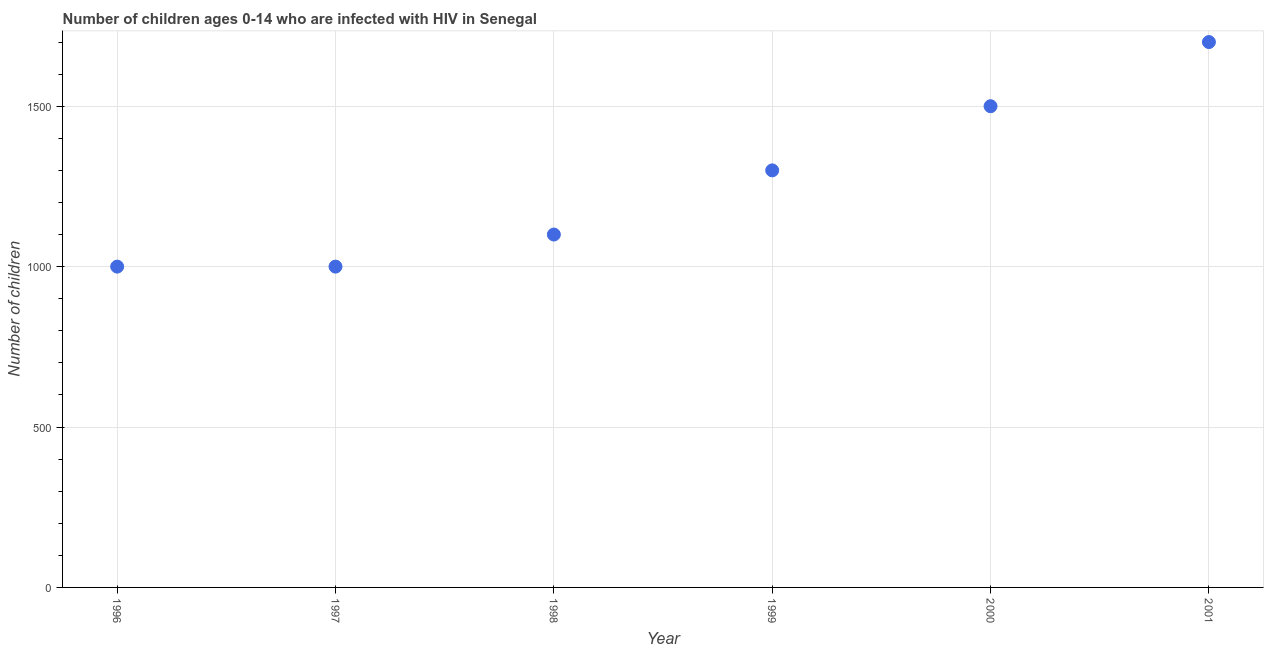What is the number of children living with hiv in 1996?
Make the answer very short. 1000. Across all years, what is the maximum number of children living with hiv?
Provide a succinct answer. 1700. Across all years, what is the minimum number of children living with hiv?
Your answer should be very brief. 1000. In which year was the number of children living with hiv maximum?
Offer a very short reply. 2001. What is the sum of the number of children living with hiv?
Make the answer very short. 7600. What is the difference between the number of children living with hiv in 1999 and 2001?
Provide a short and direct response. -400. What is the average number of children living with hiv per year?
Your answer should be very brief. 1266.67. What is the median number of children living with hiv?
Ensure brevity in your answer.  1200. In how many years, is the number of children living with hiv greater than 900 ?
Keep it short and to the point. 6. Do a majority of the years between 1997 and 1999 (inclusive) have number of children living with hiv greater than 400 ?
Make the answer very short. Yes. What is the ratio of the number of children living with hiv in 1997 to that in 2000?
Provide a succinct answer. 0.67. Is the number of children living with hiv in 1996 less than that in 1997?
Ensure brevity in your answer.  No. Is the sum of the number of children living with hiv in 1996 and 1997 greater than the maximum number of children living with hiv across all years?
Give a very brief answer. Yes. What is the difference between the highest and the lowest number of children living with hiv?
Make the answer very short. 700. In how many years, is the number of children living with hiv greater than the average number of children living with hiv taken over all years?
Your answer should be very brief. 3. How many dotlines are there?
Keep it short and to the point. 1. How many years are there in the graph?
Provide a succinct answer. 6. Does the graph contain grids?
Your answer should be compact. Yes. What is the title of the graph?
Provide a short and direct response. Number of children ages 0-14 who are infected with HIV in Senegal. What is the label or title of the Y-axis?
Provide a succinct answer. Number of children. What is the Number of children in 1997?
Your answer should be very brief. 1000. What is the Number of children in 1998?
Your answer should be very brief. 1100. What is the Number of children in 1999?
Your answer should be very brief. 1300. What is the Number of children in 2000?
Offer a very short reply. 1500. What is the Number of children in 2001?
Keep it short and to the point. 1700. What is the difference between the Number of children in 1996 and 1997?
Offer a very short reply. 0. What is the difference between the Number of children in 1996 and 1998?
Give a very brief answer. -100. What is the difference between the Number of children in 1996 and 1999?
Keep it short and to the point. -300. What is the difference between the Number of children in 1996 and 2000?
Your answer should be very brief. -500. What is the difference between the Number of children in 1996 and 2001?
Provide a succinct answer. -700. What is the difference between the Number of children in 1997 and 1998?
Offer a very short reply. -100. What is the difference between the Number of children in 1997 and 1999?
Your answer should be compact. -300. What is the difference between the Number of children in 1997 and 2000?
Give a very brief answer. -500. What is the difference between the Number of children in 1997 and 2001?
Offer a terse response. -700. What is the difference between the Number of children in 1998 and 1999?
Offer a terse response. -200. What is the difference between the Number of children in 1998 and 2000?
Provide a short and direct response. -400. What is the difference between the Number of children in 1998 and 2001?
Offer a terse response. -600. What is the difference between the Number of children in 1999 and 2000?
Offer a very short reply. -200. What is the difference between the Number of children in 1999 and 2001?
Provide a short and direct response. -400. What is the difference between the Number of children in 2000 and 2001?
Your answer should be compact. -200. What is the ratio of the Number of children in 1996 to that in 1998?
Keep it short and to the point. 0.91. What is the ratio of the Number of children in 1996 to that in 1999?
Your answer should be very brief. 0.77. What is the ratio of the Number of children in 1996 to that in 2000?
Your answer should be compact. 0.67. What is the ratio of the Number of children in 1996 to that in 2001?
Your answer should be very brief. 0.59. What is the ratio of the Number of children in 1997 to that in 1998?
Your answer should be compact. 0.91. What is the ratio of the Number of children in 1997 to that in 1999?
Provide a short and direct response. 0.77. What is the ratio of the Number of children in 1997 to that in 2000?
Offer a very short reply. 0.67. What is the ratio of the Number of children in 1997 to that in 2001?
Provide a short and direct response. 0.59. What is the ratio of the Number of children in 1998 to that in 1999?
Your answer should be very brief. 0.85. What is the ratio of the Number of children in 1998 to that in 2000?
Make the answer very short. 0.73. What is the ratio of the Number of children in 1998 to that in 2001?
Your answer should be very brief. 0.65. What is the ratio of the Number of children in 1999 to that in 2000?
Your answer should be very brief. 0.87. What is the ratio of the Number of children in 1999 to that in 2001?
Your response must be concise. 0.77. What is the ratio of the Number of children in 2000 to that in 2001?
Provide a short and direct response. 0.88. 